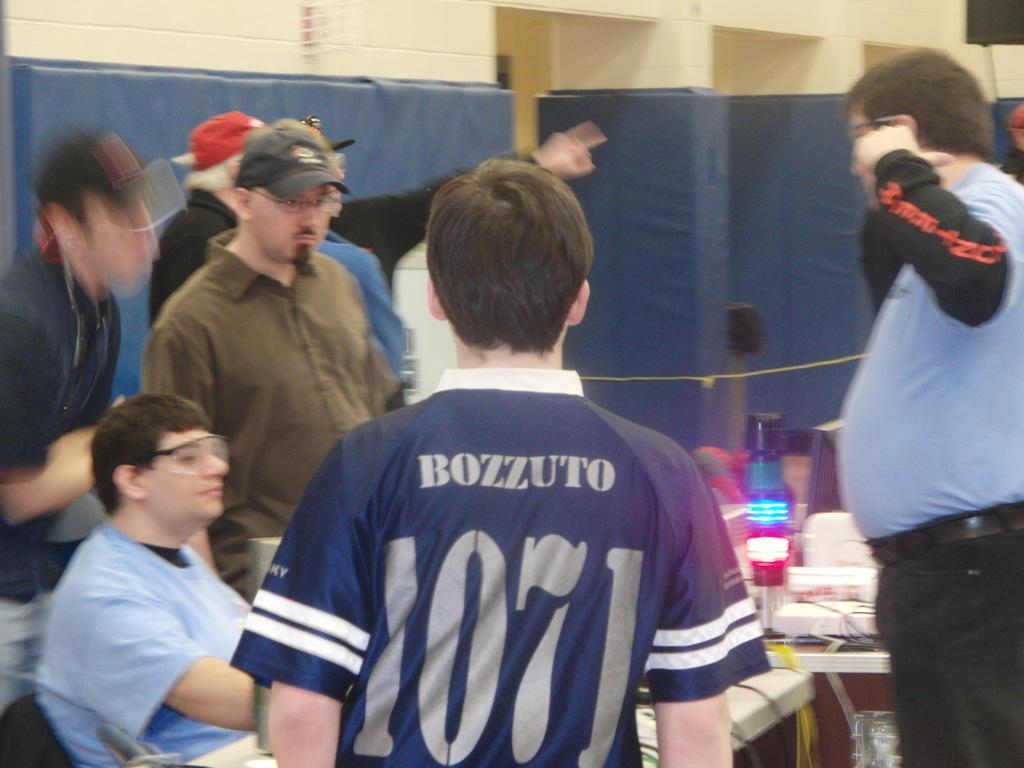<image>
Offer a succinct explanation of the picture presented. a player that has the name Bozzuto on the back of their jersey 